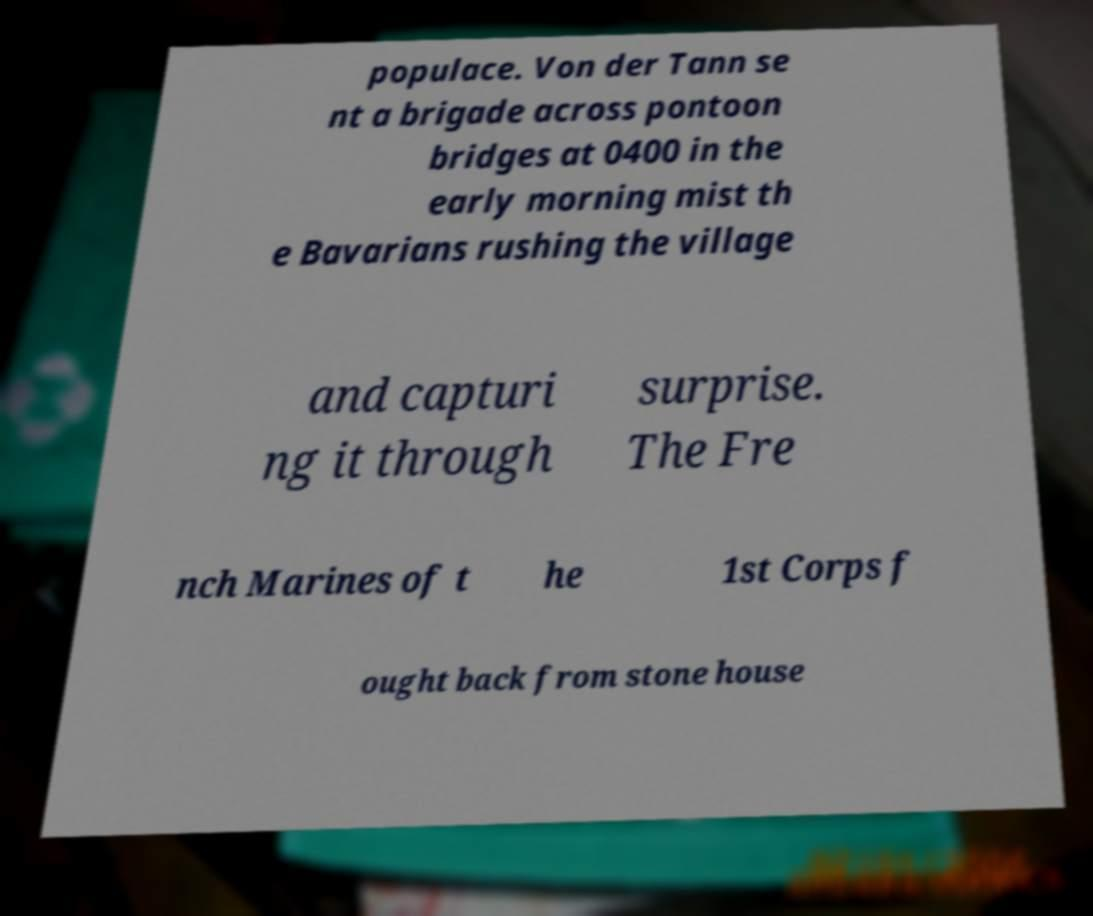Please read and relay the text visible in this image. What does it say? populace. Von der Tann se nt a brigade across pontoon bridges at 0400 in the early morning mist th e Bavarians rushing the village and capturi ng it through surprise. The Fre nch Marines of t he 1st Corps f ought back from stone house 